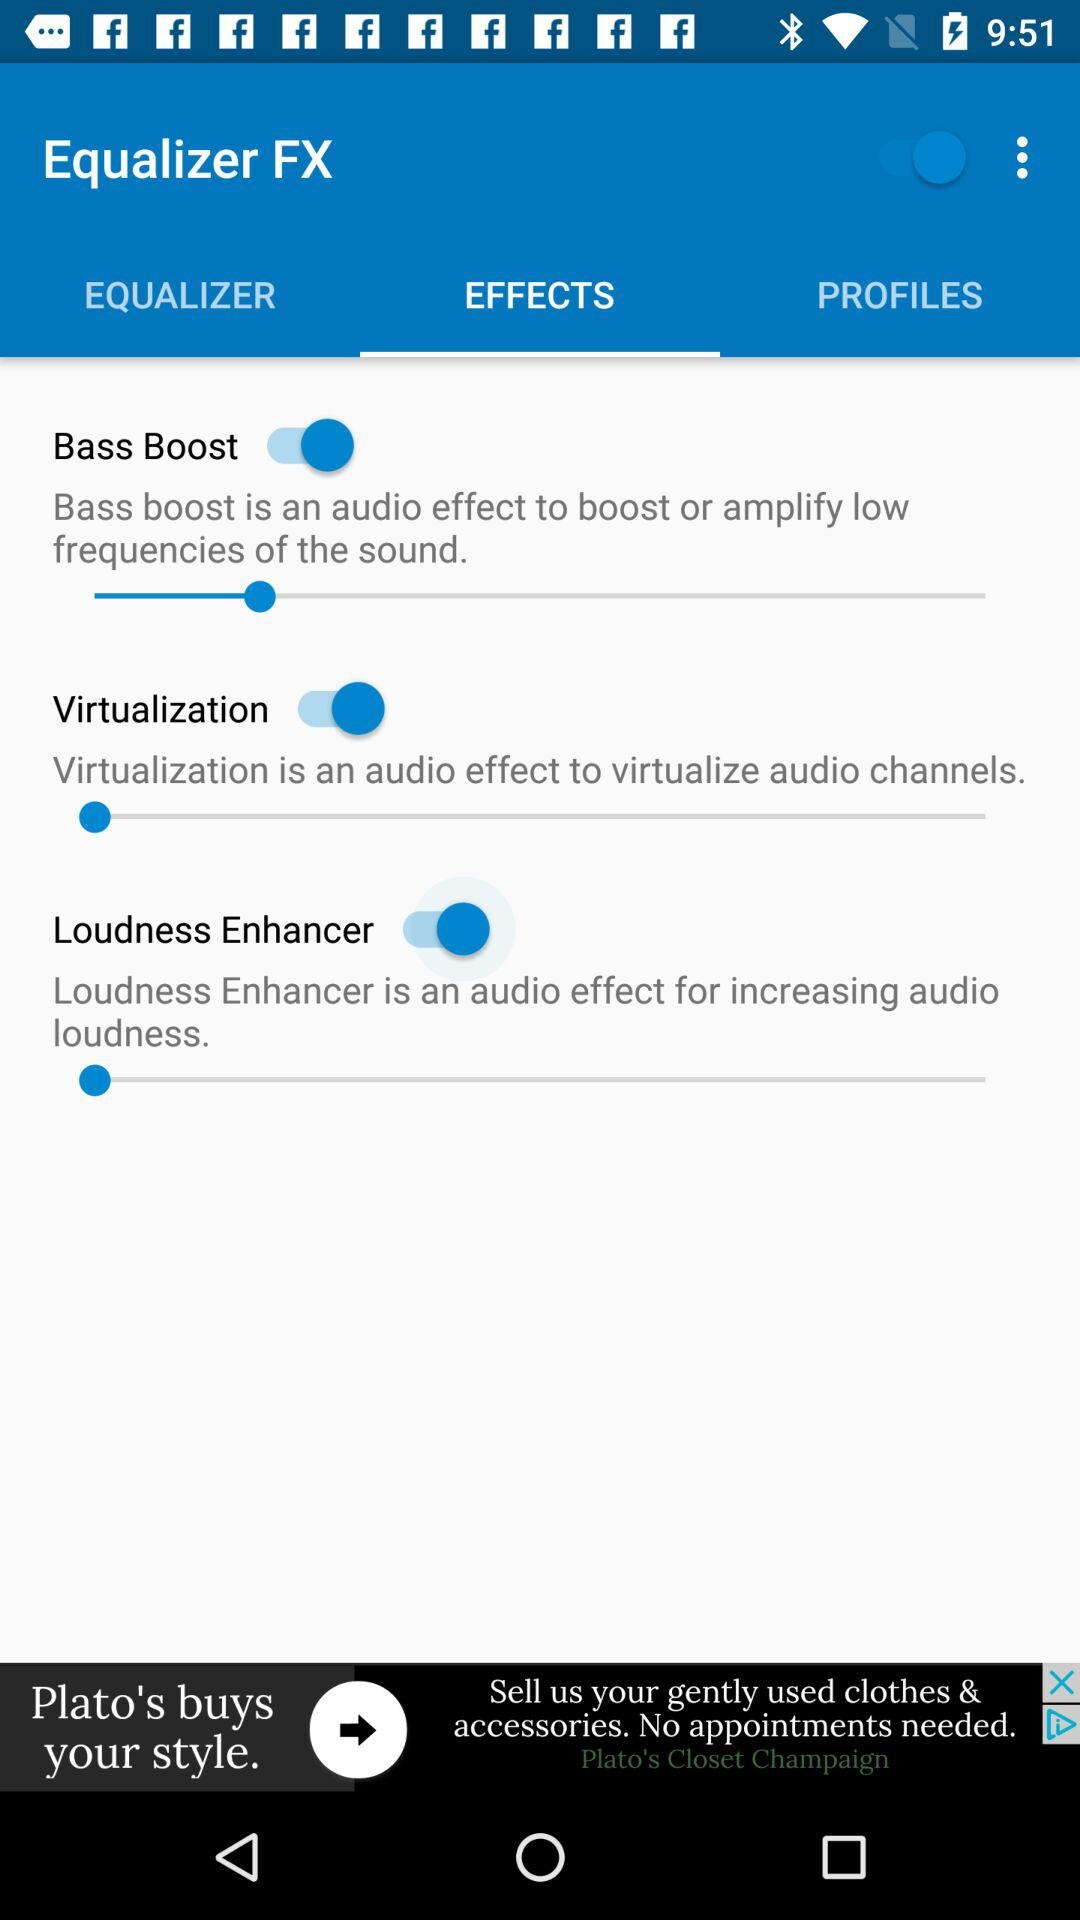How many audio effects are there?
Answer the question using a single word or phrase. 3 